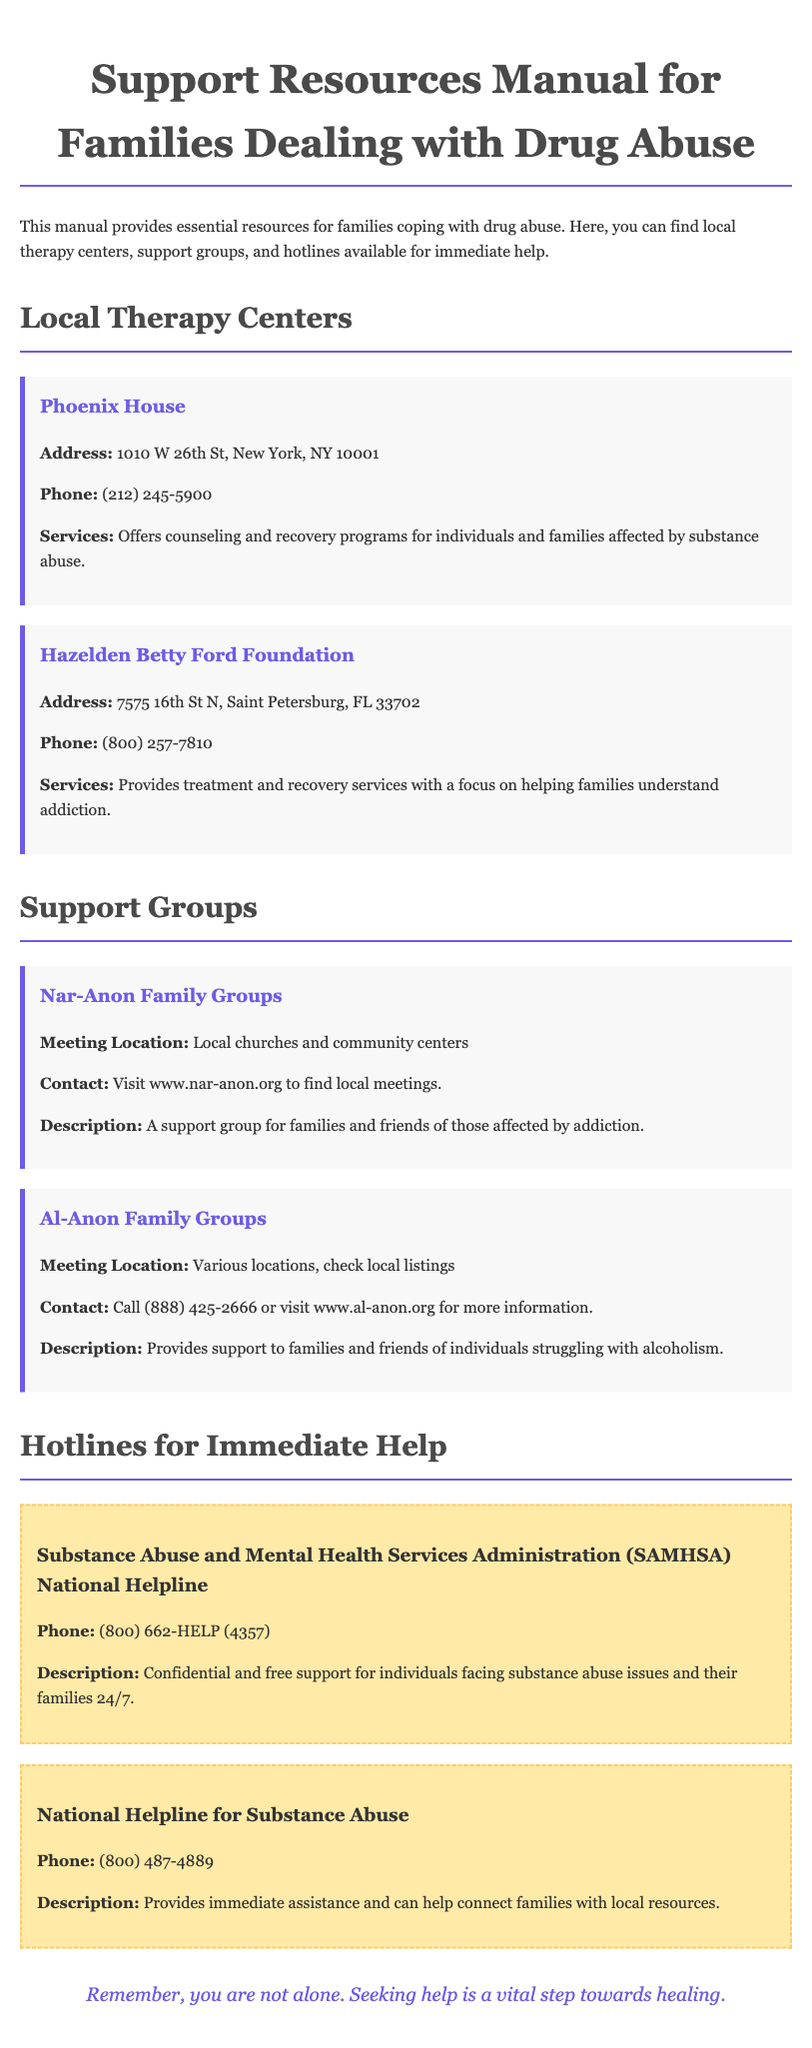What is the address of Phoenix House? The address is stated in the section about Local Therapy Centers.
Answer: 1010 W 26th St, New York, NY 10001 What type of support does Hazelden Betty Ford Foundation provide? The document mentions the services offered by therapy centers, including Hazelden Betty Ford Foundation.
Answer: Treatment and recovery services What is the contact number for Al-Anon Family Groups? The contact information is provided in the Support Groups section.
Answer: (888) 425-2666 Which hotline provides confidential support 24/7? The document specifies hotlines for immediate help, among which one offers 24/7 support.
Answer: SAMHSA National Helpline Where can I find local Nar-Anon meetings? This information is included in the description of the Nar-Anon Family Groups.
Answer: www.nar-anon.org What is the purpose of the document? The introductory paragraph explains the main intent of the manual.
Answer: Essential resources for families coping with drug abuse What should families do if they need immediate assistance? The conclusion provides guidance on taking action in times of need.
Answer: Seek help 